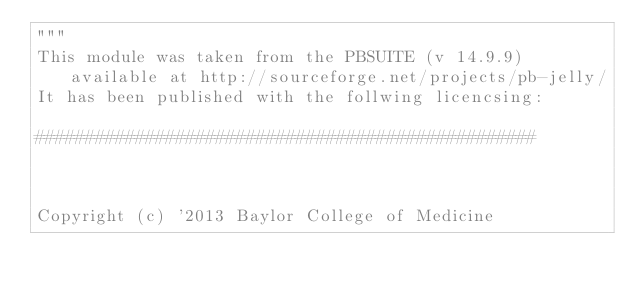<code> <loc_0><loc_0><loc_500><loc_500><_Python_>"""
This module was taken from the PBSUITE (v 14.9.9) available at http://sourceforge.net/projects/pb-jelly/
It has been published with the follwing licencsing:

##################################################



Copyright (c) '2013 Baylor College of Medicine</code> 